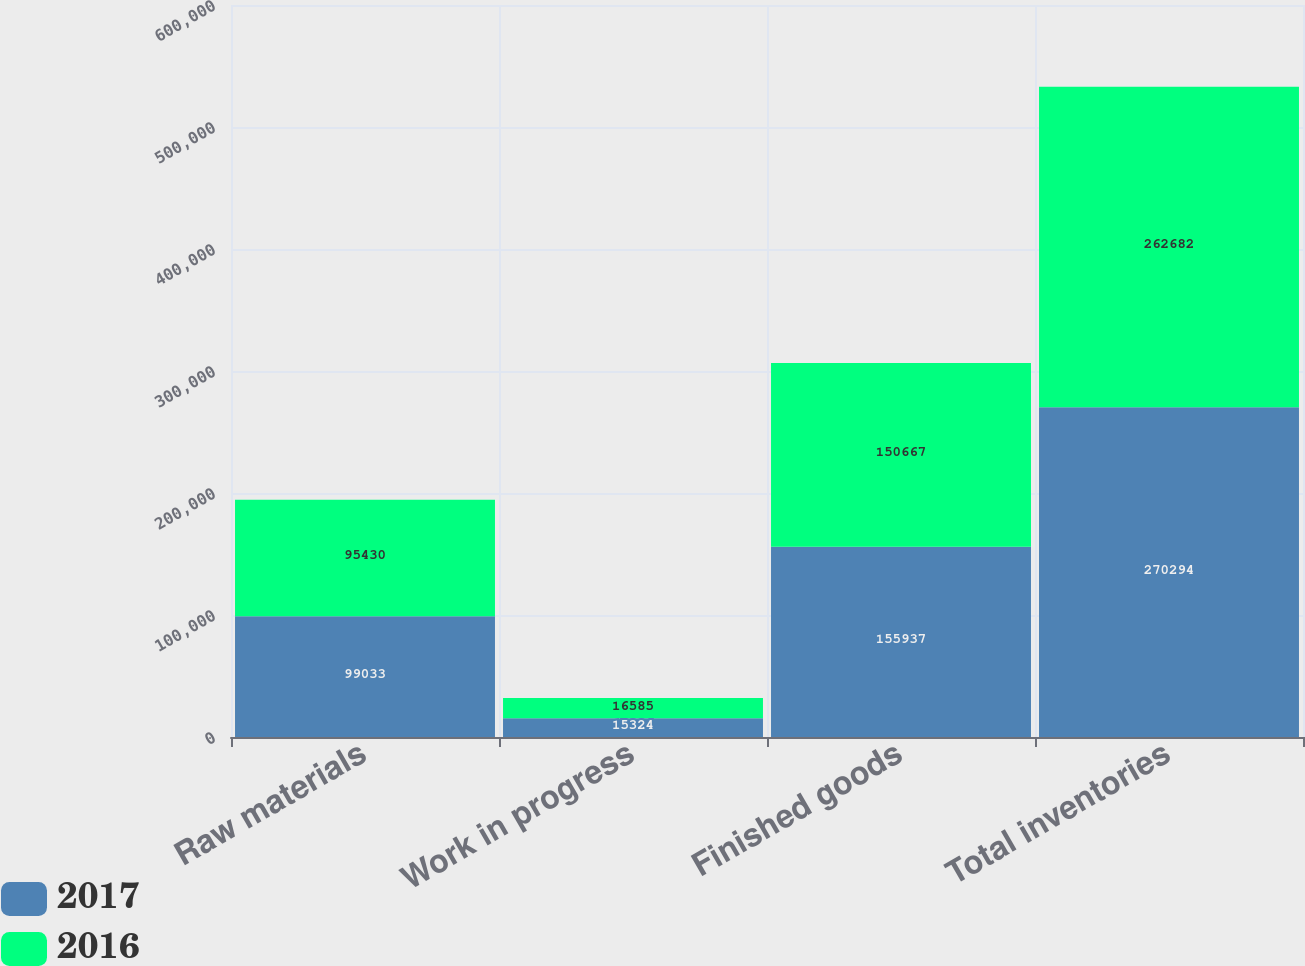Convert chart to OTSL. <chart><loc_0><loc_0><loc_500><loc_500><stacked_bar_chart><ecel><fcel>Raw materials<fcel>Work in progress<fcel>Finished goods<fcel>Total inventories<nl><fcel>2017<fcel>99033<fcel>15324<fcel>155937<fcel>270294<nl><fcel>2016<fcel>95430<fcel>16585<fcel>150667<fcel>262682<nl></chart> 